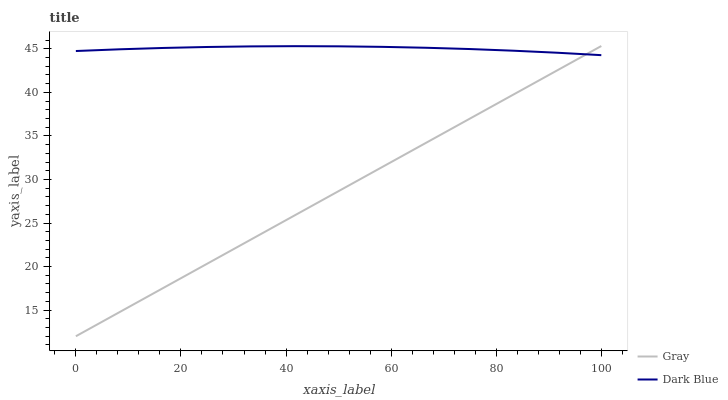Does Gray have the minimum area under the curve?
Answer yes or no. Yes. Does Dark Blue have the maximum area under the curve?
Answer yes or no. Yes. Does Dark Blue have the minimum area under the curve?
Answer yes or no. No. Is Gray the smoothest?
Answer yes or no. Yes. Is Dark Blue the roughest?
Answer yes or no. Yes. Is Dark Blue the smoothest?
Answer yes or no. No. Does Gray have the lowest value?
Answer yes or no. Yes. Does Dark Blue have the lowest value?
Answer yes or no. No. Does Gray have the highest value?
Answer yes or no. Yes. Does Dark Blue have the highest value?
Answer yes or no. No. Does Gray intersect Dark Blue?
Answer yes or no. Yes. Is Gray less than Dark Blue?
Answer yes or no. No. Is Gray greater than Dark Blue?
Answer yes or no. No. 